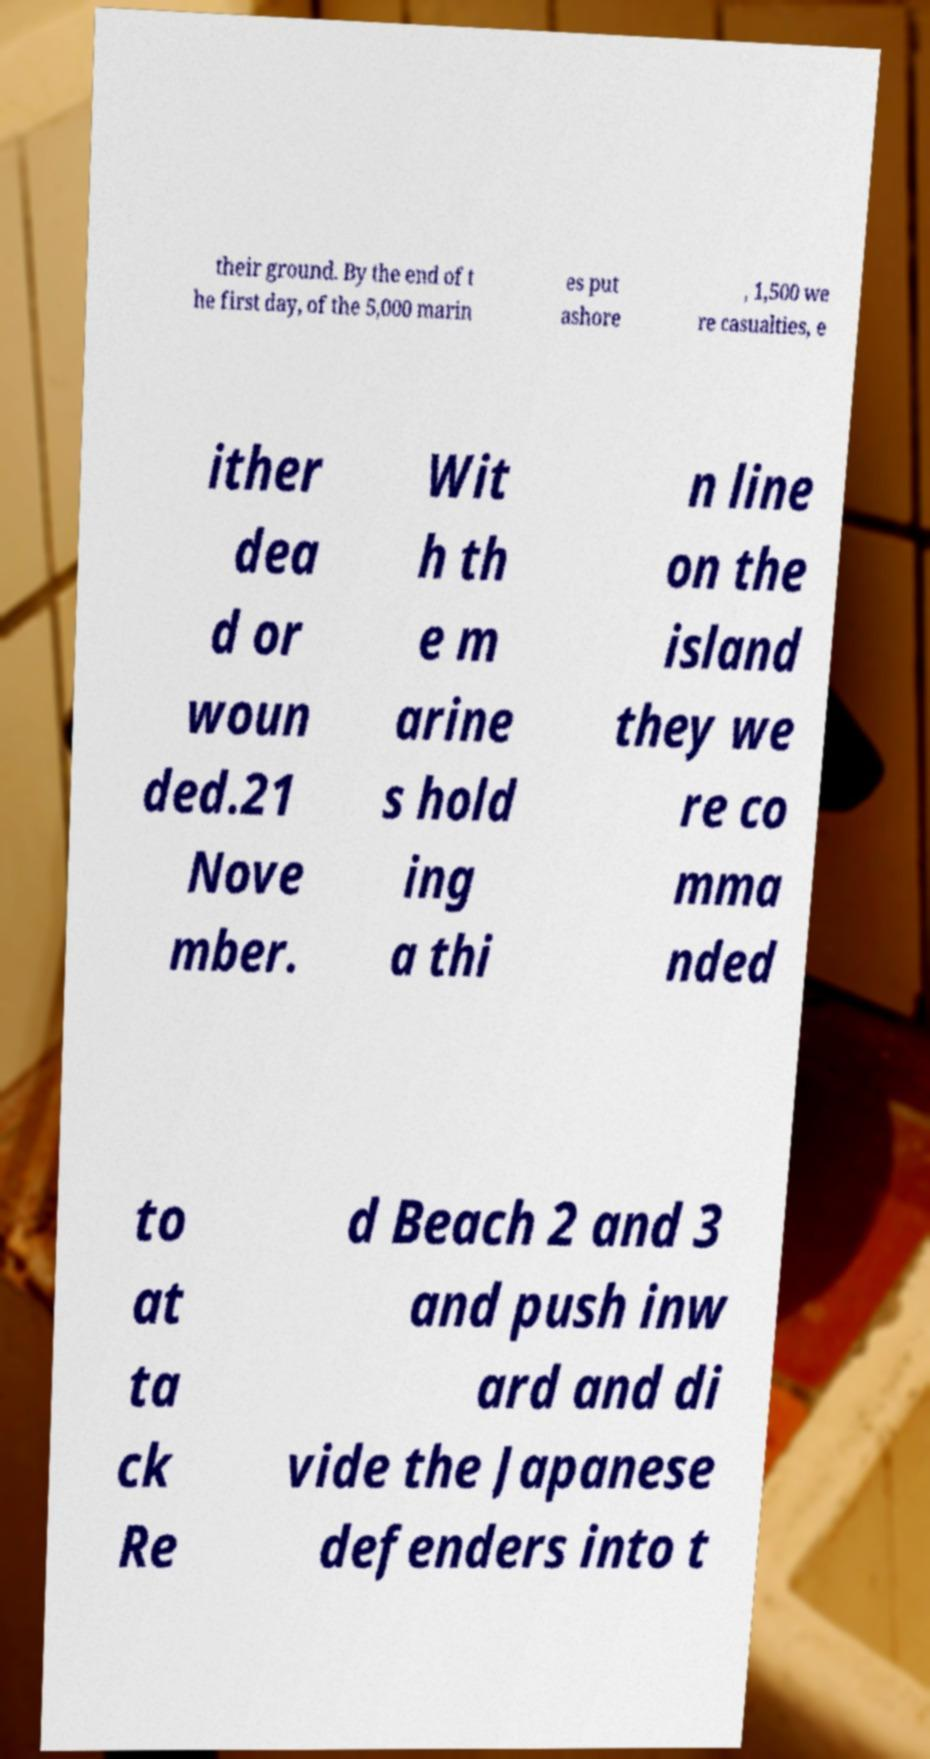Please identify and transcribe the text found in this image. their ground. By the end of t he first day, of the 5,000 marin es put ashore , 1,500 we re casualties, e ither dea d or woun ded.21 Nove mber. Wit h th e m arine s hold ing a thi n line on the island they we re co mma nded to at ta ck Re d Beach 2 and 3 and push inw ard and di vide the Japanese defenders into t 